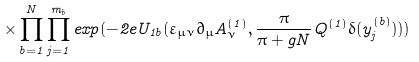Convert formula to latex. <formula><loc_0><loc_0><loc_500><loc_500>\times \prod _ { b = 1 } ^ { N } \prod _ { j = 1 } ^ { m _ { b } } e x p ( - 2 e U _ { 1 b } ( \varepsilon _ { \mu \nu } \partial _ { \mu } A _ { \nu } ^ { ( 1 ) } , \frac { \pi } { \pi + g N } Q ^ { ( 1 ) } \delta ( y _ { j } ^ { ( b ) } ) ) )</formula> 